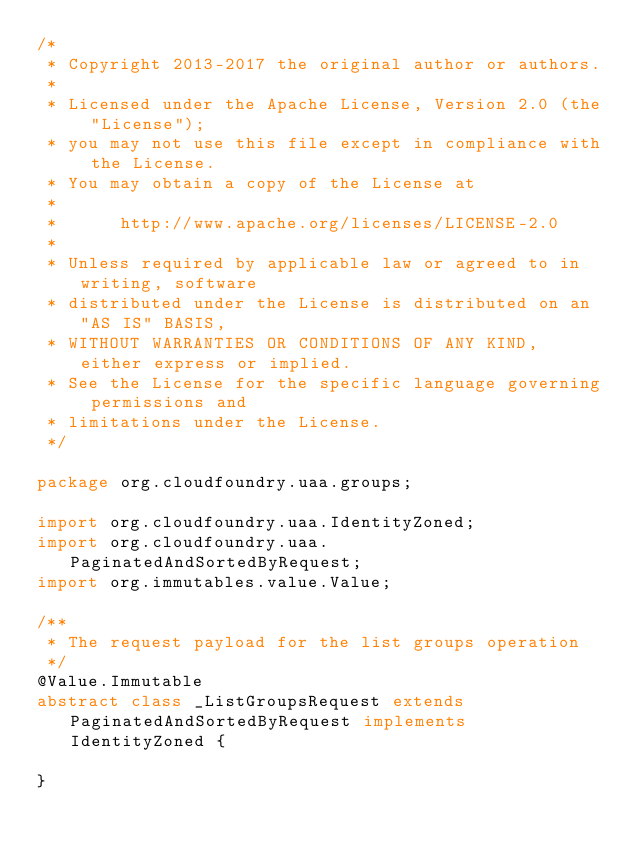<code> <loc_0><loc_0><loc_500><loc_500><_Java_>/*
 * Copyright 2013-2017 the original author or authors.
 *
 * Licensed under the Apache License, Version 2.0 (the "License");
 * you may not use this file except in compliance with the License.
 * You may obtain a copy of the License at
 *
 *      http://www.apache.org/licenses/LICENSE-2.0
 *
 * Unless required by applicable law or agreed to in writing, software
 * distributed under the License is distributed on an "AS IS" BASIS,
 * WITHOUT WARRANTIES OR CONDITIONS OF ANY KIND, either express or implied.
 * See the License for the specific language governing permissions and
 * limitations under the License.
 */

package org.cloudfoundry.uaa.groups;

import org.cloudfoundry.uaa.IdentityZoned;
import org.cloudfoundry.uaa.PaginatedAndSortedByRequest;
import org.immutables.value.Value;

/**
 * The request payload for the list groups operation
 */
@Value.Immutable
abstract class _ListGroupsRequest extends PaginatedAndSortedByRequest implements IdentityZoned {

}
</code> 